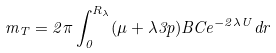<formula> <loc_0><loc_0><loc_500><loc_500>m _ { T } = 2 \pi \int _ { 0 } ^ { R _ { \lambda } } ( \mu + \lambda 3 p ) B C e ^ { - 2 \lambda U } d r</formula> 